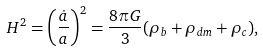Convert formula to latex. <formula><loc_0><loc_0><loc_500><loc_500>H ^ { 2 } = \left ( \frac { \dot { a } } { a } \right ) ^ { 2 } = \frac { 8 \pi G } { 3 } ( \rho _ { b } + \rho _ { d m } + \rho _ { c } ) ,</formula> 